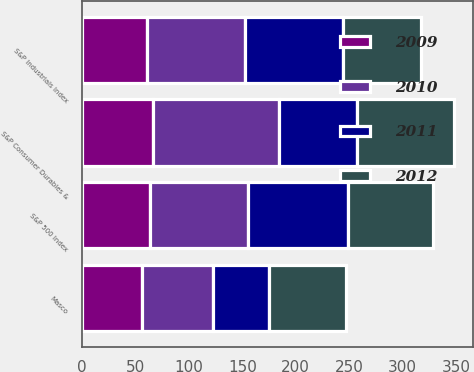<chart> <loc_0><loc_0><loc_500><loc_500><stacked_bar_chart><ecel><fcel>Masco<fcel>S&P 500 Index<fcel>S&P Industrials Index<fcel>S&P Consumer Durables &<nl><fcel>2009<fcel>55.78<fcel>63.45<fcel>60.6<fcel>66.43<nl><fcel>2012<fcel>71.52<fcel>79.9<fcel>72.83<fcel>90.54<nl><fcel>2010<fcel>67.12<fcel>91.74<fcel>92.04<fcel>118.19<nl><fcel>2011<fcel>52.15<fcel>93.67<fcel>91.5<fcel>72.83<nl></chart> 